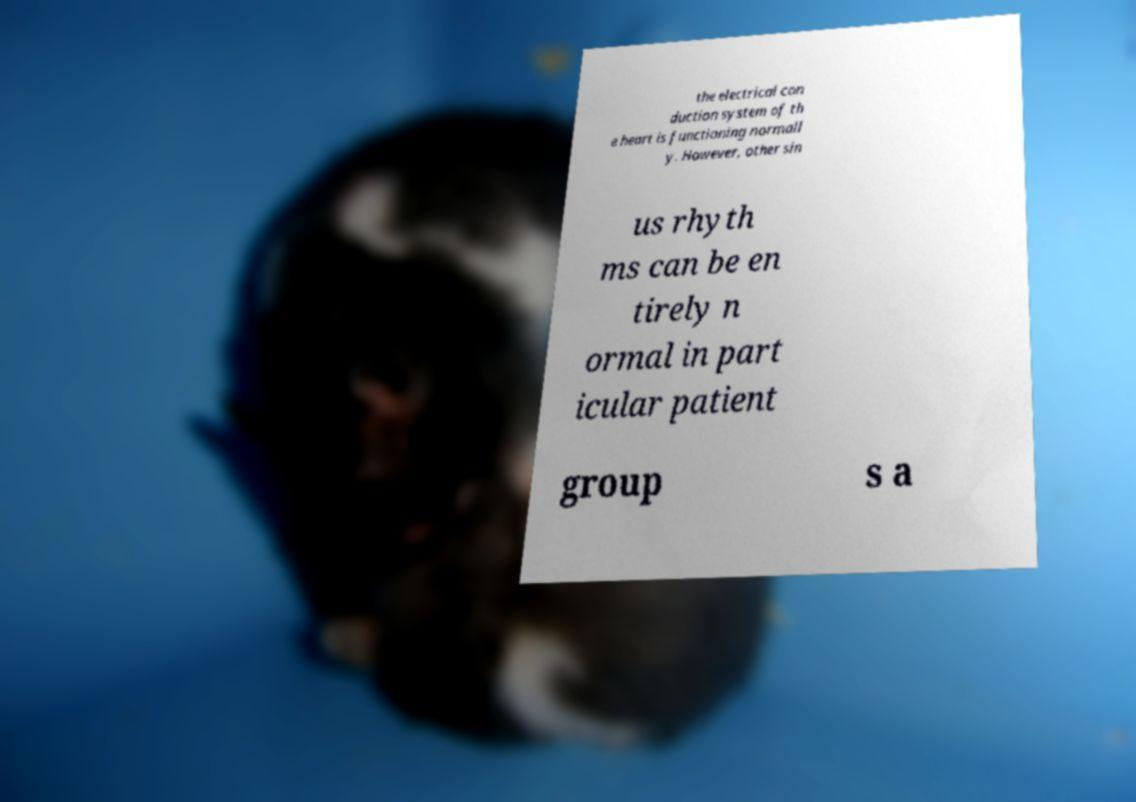Please identify and transcribe the text found in this image. the electrical con duction system of th e heart is functioning normall y. However, other sin us rhyth ms can be en tirely n ormal in part icular patient group s a 